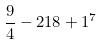<formula> <loc_0><loc_0><loc_500><loc_500>\frac { 9 } { 4 } - 2 1 8 + 1 ^ { 7 }</formula> 